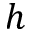Convert formula to latex. <formula><loc_0><loc_0><loc_500><loc_500>h</formula> 